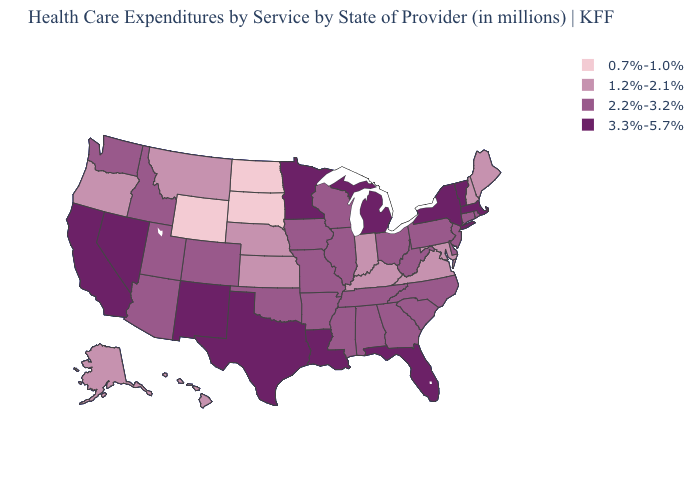Does South Dakota have the lowest value in the USA?
Concise answer only. Yes. Does the first symbol in the legend represent the smallest category?
Short answer required. Yes. What is the value of Oregon?
Short answer required. 1.2%-2.1%. Among the states that border California , which have the highest value?
Quick response, please. Nevada. What is the lowest value in the USA?
Quick response, please. 0.7%-1.0%. What is the value of West Virginia?
Write a very short answer. 2.2%-3.2%. Name the states that have a value in the range 2.2%-3.2%?
Quick response, please. Alabama, Arizona, Arkansas, Colorado, Connecticut, Delaware, Georgia, Idaho, Illinois, Iowa, Mississippi, Missouri, New Jersey, North Carolina, Ohio, Oklahoma, Pennsylvania, Rhode Island, South Carolina, Tennessee, Utah, Washington, West Virginia, Wisconsin. What is the lowest value in the South?
Keep it brief. 1.2%-2.1%. How many symbols are there in the legend?
Keep it brief. 4. Which states hav the highest value in the South?
Keep it brief. Florida, Louisiana, Texas. Does Minnesota have the highest value in the MidWest?
Short answer required. Yes. What is the lowest value in the USA?
Concise answer only. 0.7%-1.0%. What is the value of Tennessee?
Quick response, please. 2.2%-3.2%. What is the value of Michigan?
Answer briefly. 3.3%-5.7%. Is the legend a continuous bar?
Give a very brief answer. No. 